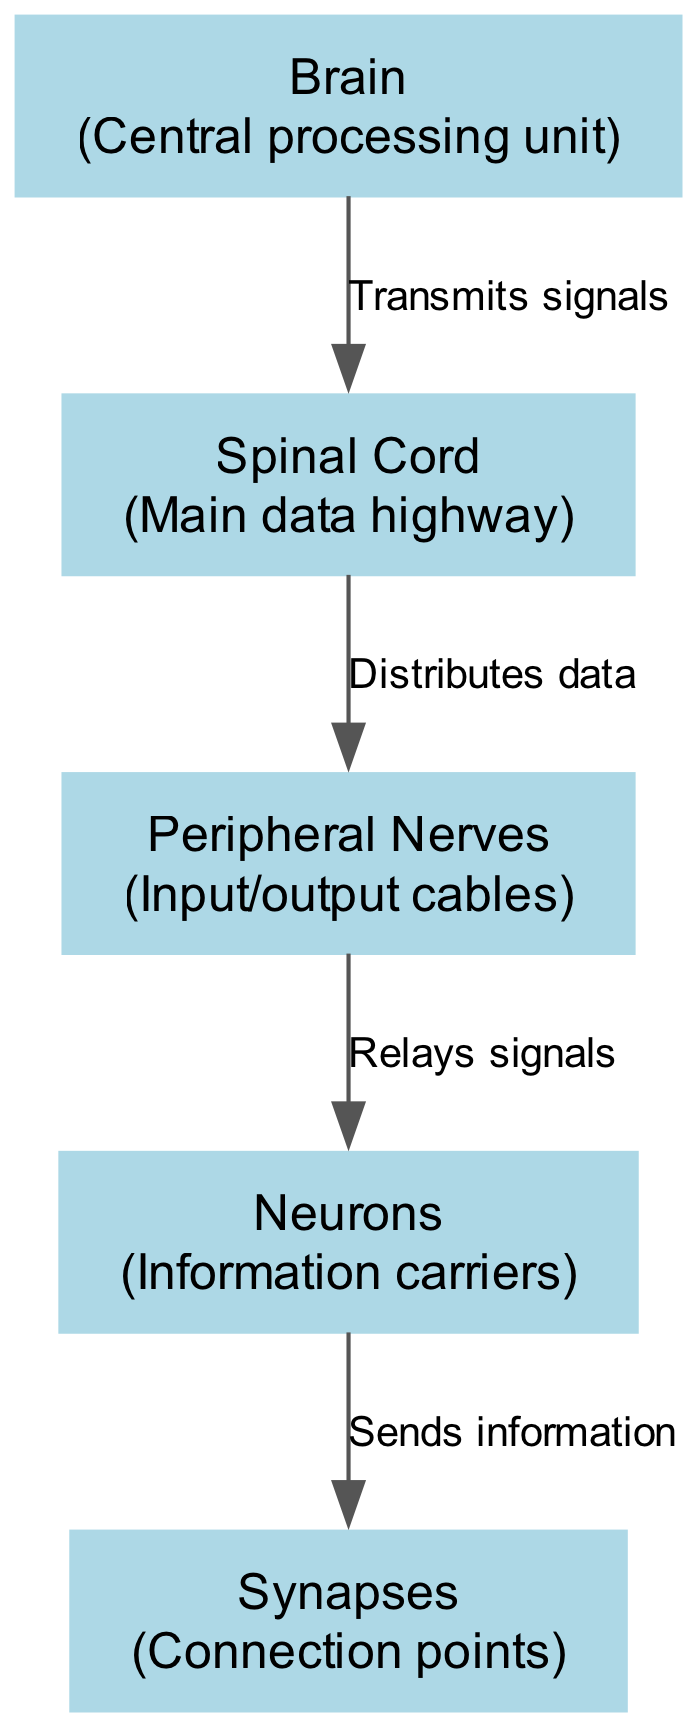What is the central processing unit in the nervous system? The "Brain" node is labeled as the central processing unit within the nervous system diagram.
Answer: Brain How many nodes are present in this diagram? By counting the nodes listed in the data section, we find there are five nodes: brain, spinal cord, peripheral nerves, neurons, and synapses.
Answer: 5 What is the role of the spinal cord? The spinal cord is described in the diagram as the "Main data highway," indicating its function to transmit information.
Answer: Main data highway Which node sends information to the synapses? According to the diagram, the "Neurons" node is responsible for sending information to the "Synapses" node.
Answer: Neurons What type of connection points are represented in the diagram? The "Synapses" node represents the connection points in the nervous system, facilitating interactions between neurons.
Answer: Connection points What does the brain do with signals? The diagram states that the brain "Transmits signals" to the spinal cord, indicating its role in signal processing and distribution.
Answer: Transmits signals How does the spinal cord interact with peripheral nerves? The diagram shows that the spinal cord "Distributes data" to the peripheral nerves, indicating a pathway of information flow.
Answer: Distributes data Which nodes are directly connected by a relay of signals? The "Peripheral Nerves" node relays signals to the "Neurons" node in the diagram, establishing a crucial communication link.
Answer: Peripheral Nerves, Neurons What is the relationship between neurons and synapses? The diagram indicates that neurons "Send information" to synapses, highlighting their interdependent function in the signal transmission process.
Answer: Sends information 